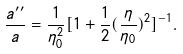<formula> <loc_0><loc_0><loc_500><loc_500>\frac { a ^ { \prime \prime } } { a } = \frac { 1 } { \eta _ { 0 } ^ { 2 } } [ 1 + \frac { 1 } { 2 } ( \frac { \eta } { \eta _ { 0 } } ) ^ { 2 } ] ^ { - 1 } .</formula> 